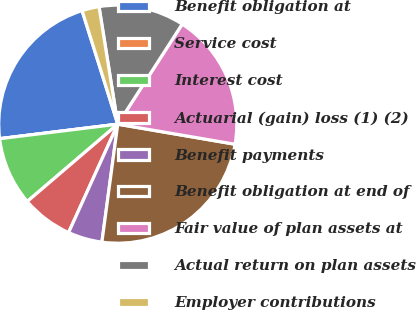Convert chart to OTSL. <chart><loc_0><loc_0><loc_500><loc_500><pie_chart><fcel>Benefit obligation at<fcel>Service cost<fcel>Interest cost<fcel>Actuarial (gain) loss (1) (2)<fcel>Benefit payments<fcel>Benefit obligation at end of<fcel>Fair value of plan assets at<fcel>Actual return on plan assets<fcel>Employer contributions<nl><fcel>22.1%<fcel>0.0%<fcel>9.3%<fcel>6.97%<fcel>4.65%<fcel>24.43%<fcel>18.59%<fcel>11.62%<fcel>2.33%<nl></chart> 